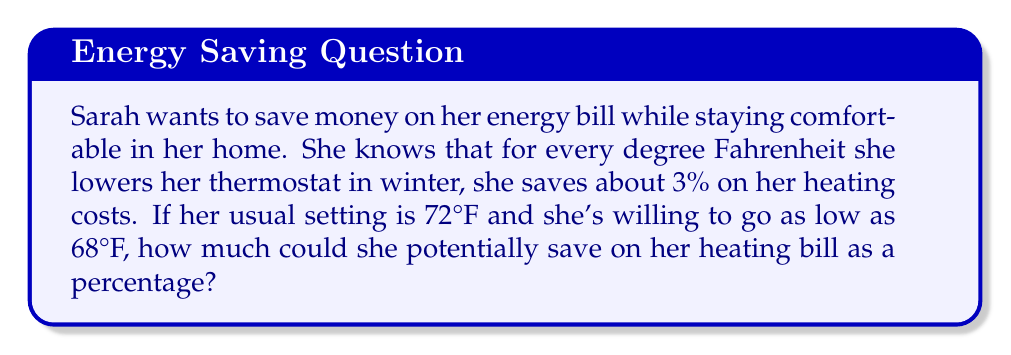Help me with this question. Let's approach this step-by-step:

1. First, we need to calculate how many degrees Sarah can lower her thermostat:
   $72°F - 68°F = 4°F$

2. We're told that for each degree lowered, Sarah saves 3% on her heating costs.
   So, we can set up an equation:
   $\text{Savings} = 3\% \times \text{Number of degrees lowered}$

3. Plugging in our numbers:
   $\text{Savings} = 3\% \times 4$

4. To calculate this:
   $3\% = 0.03$ (converting percentage to decimal)
   $0.03 \times 4 = 0.12$

5. Converting back to a percentage:
   $0.12 = 12\%$

Therefore, by lowering her thermostat from 72°F to 68°F, Sarah could potentially save 12% on her heating bill.
Answer: 12% 